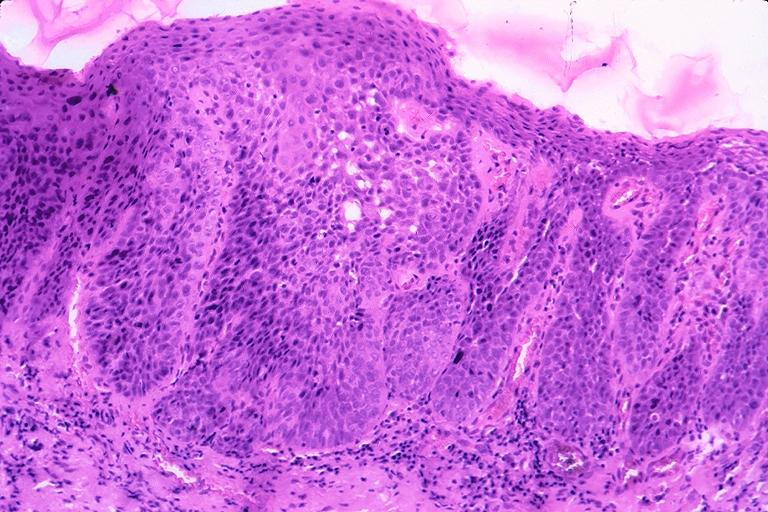s adenosis and ischemia present?
Answer the question using a single word or phrase. No 